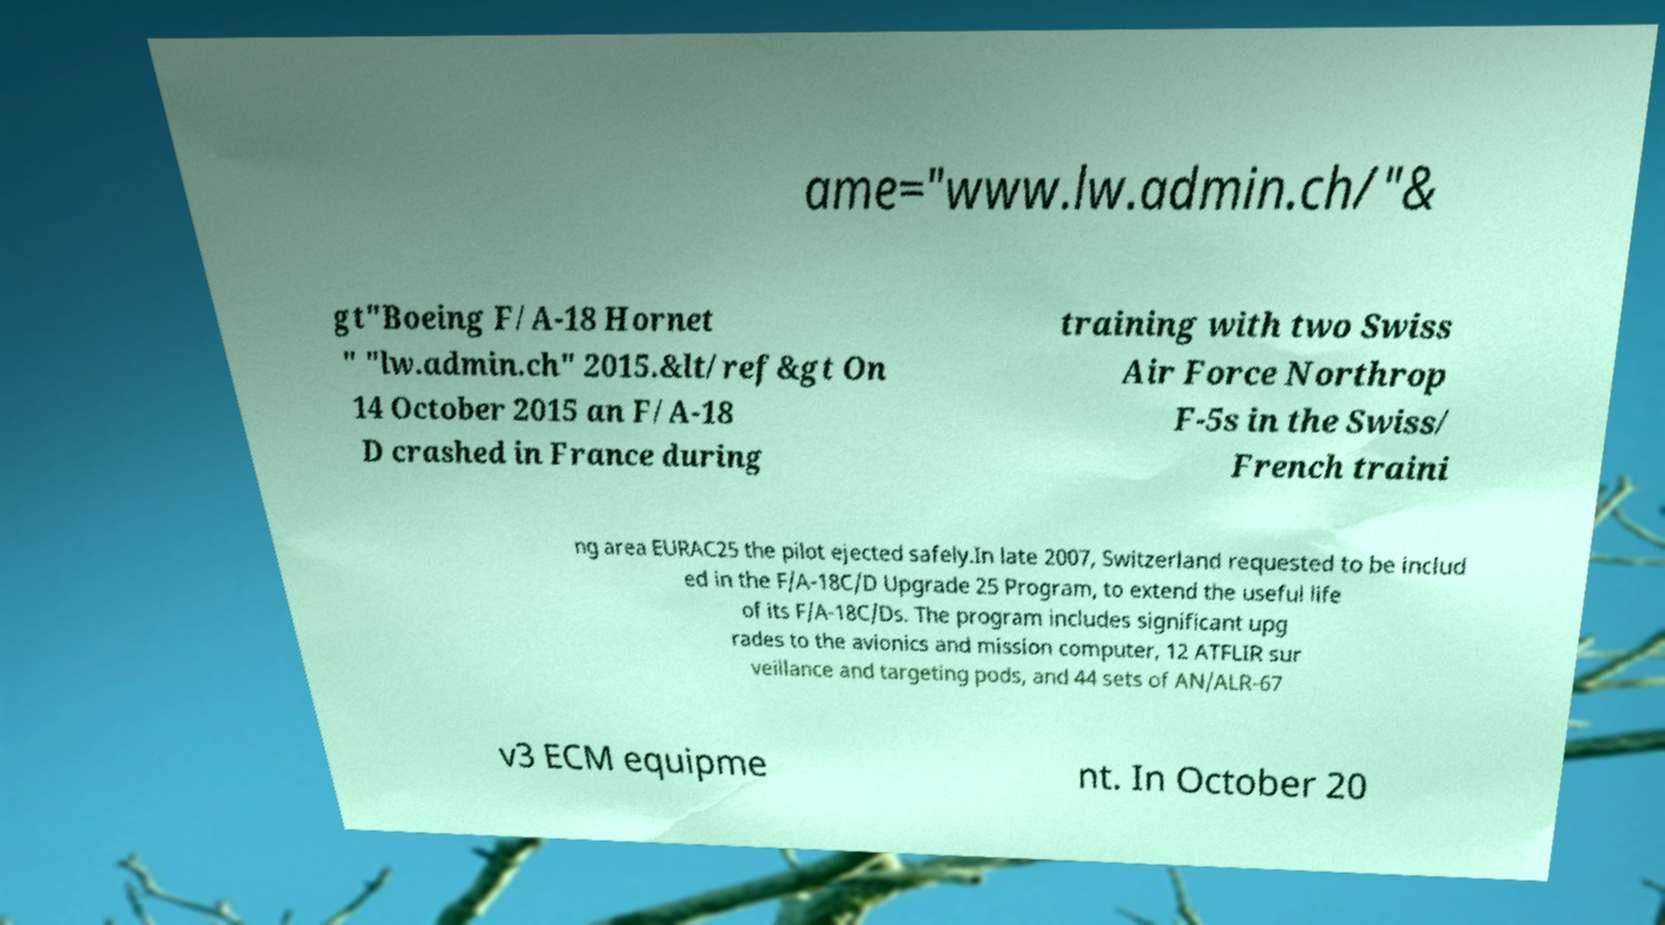What messages or text are displayed in this image? I need them in a readable, typed format. ame="www.lw.admin.ch/"& gt"Boeing F/A-18 Hornet " "lw.admin.ch" 2015.&lt/ref&gt On 14 October 2015 an F/A-18 D crashed in France during training with two Swiss Air Force Northrop F-5s in the Swiss/ French traini ng area EURAC25 the pilot ejected safely.In late 2007, Switzerland requested to be includ ed in the F/A-18C/D Upgrade 25 Program, to extend the useful life of its F/A-18C/Ds. The program includes significant upg rades to the avionics and mission computer, 12 ATFLIR sur veillance and targeting pods, and 44 sets of AN/ALR-67 v3 ECM equipme nt. In October 20 